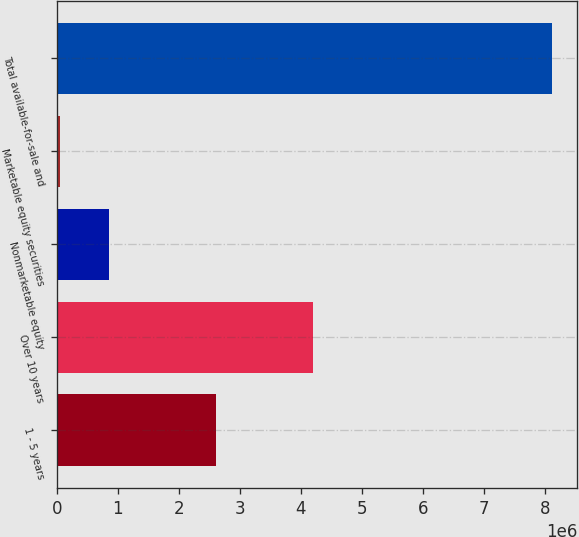Convert chart to OTSL. <chart><loc_0><loc_0><loc_500><loc_500><bar_chart><fcel>1 - 5 years<fcel>Over 10 years<fcel>Nonmarketable equity<fcel>Marketable equity securities<fcel>Total available-for-sale and<nl><fcel>2.60866e+06<fcel>4.20105e+06<fcel>860694<fcel>53665<fcel>8.12395e+06<nl></chart> 